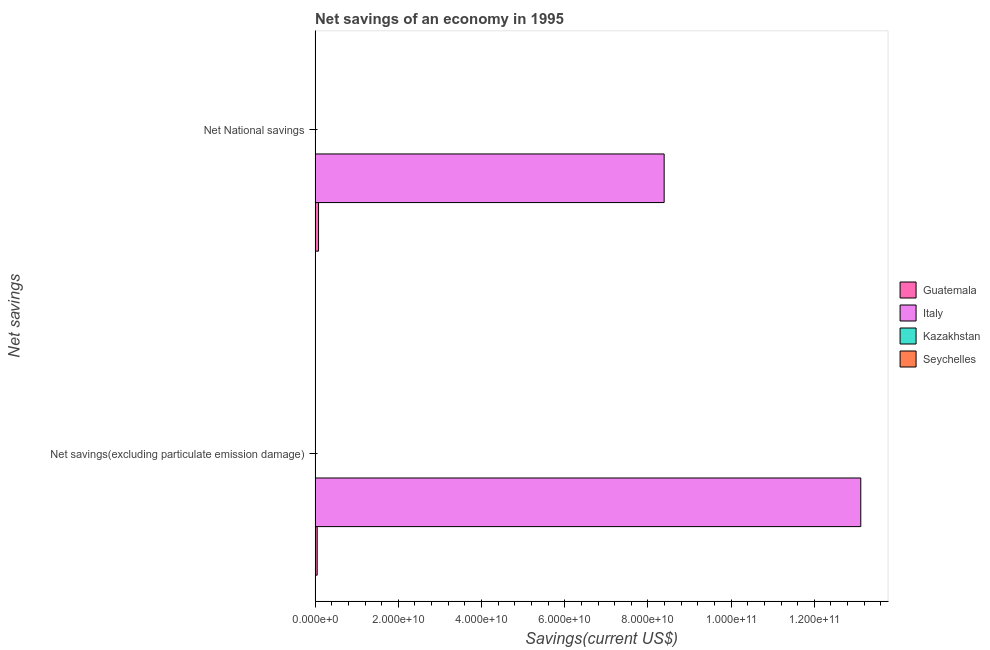How many groups of bars are there?
Your answer should be very brief. 2. How many bars are there on the 1st tick from the top?
Keep it short and to the point. 2. How many bars are there on the 1st tick from the bottom?
Your answer should be very brief. 2. What is the label of the 2nd group of bars from the top?
Keep it short and to the point. Net savings(excluding particulate emission damage). What is the net savings(excluding particulate emission damage) in Seychelles?
Keep it short and to the point. 0. Across all countries, what is the maximum net national savings?
Make the answer very short. 8.39e+1. In which country was the net savings(excluding particulate emission damage) maximum?
Offer a terse response. Italy. What is the total net savings(excluding particulate emission damage) in the graph?
Keep it short and to the point. 1.32e+11. What is the difference between the net savings(excluding particulate emission damage) in Italy and that in Guatemala?
Ensure brevity in your answer.  1.31e+11. What is the difference between the net national savings in Italy and the net savings(excluding particulate emission damage) in Guatemala?
Offer a very short reply. 8.34e+1. What is the average net savings(excluding particulate emission damage) per country?
Your response must be concise. 3.29e+1. What is the difference between the net national savings and net savings(excluding particulate emission damage) in Guatemala?
Ensure brevity in your answer.  3.26e+08. What is the ratio of the net national savings in Guatemala to that in Italy?
Offer a very short reply. 0.01. Is the net national savings in Guatemala less than that in Italy?
Offer a terse response. Yes. Are all the bars in the graph horizontal?
Give a very brief answer. Yes. Are the values on the major ticks of X-axis written in scientific E-notation?
Provide a succinct answer. Yes. How many legend labels are there?
Give a very brief answer. 4. How are the legend labels stacked?
Your answer should be very brief. Vertical. What is the title of the graph?
Your response must be concise. Net savings of an economy in 1995. What is the label or title of the X-axis?
Your answer should be compact. Savings(current US$). What is the label or title of the Y-axis?
Give a very brief answer. Net savings. What is the Savings(current US$) in Guatemala in Net savings(excluding particulate emission damage)?
Ensure brevity in your answer.  5.01e+08. What is the Savings(current US$) in Italy in Net savings(excluding particulate emission damage)?
Your response must be concise. 1.31e+11. What is the Savings(current US$) in Seychelles in Net savings(excluding particulate emission damage)?
Your response must be concise. 0. What is the Savings(current US$) in Guatemala in Net National savings?
Keep it short and to the point. 8.27e+08. What is the Savings(current US$) in Italy in Net National savings?
Give a very brief answer. 8.39e+1. What is the Savings(current US$) of Seychelles in Net National savings?
Keep it short and to the point. 0. Across all Net savings, what is the maximum Savings(current US$) in Guatemala?
Your response must be concise. 8.27e+08. Across all Net savings, what is the maximum Savings(current US$) of Italy?
Your response must be concise. 1.31e+11. Across all Net savings, what is the minimum Savings(current US$) of Guatemala?
Ensure brevity in your answer.  5.01e+08. Across all Net savings, what is the minimum Savings(current US$) in Italy?
Keep it short and to the point. 8.39e+1. What is the total Savings(current US$) in Guatemala in the graph?
Give a very brief answer. 1.33e+09. What is the total Savings(current US$) of Italy in the graph?
Give a very brief answer. 2.15e+11. What is the total Savings(current US$) in Kazakhstan in the graph?
Give a very brief answer. 0. What is the difference between the Savings(current US$) of Guatemala in Net savings(excluding particulate emission damage) and that in Net National savings?
Your answer should be very brief. -3.26e+08. What is the difference between the Savings(current US$) of Italy in Net savings(excluding particulate emission damage) and that in Net National savings?
Your response must be concise. 4.73e+1. What is the difference between the Savings(current US$) in Guatemala in Net savings(excluding particulate emission damage) and the Savings(current US$) in Italy in Net National savings?
Keep it short and to the point. -8.34e+1. What is the average Savings(current US$) in Guatemala per Net savings?
Offer a very short reply. 6.64e+08. What is the average Savings(current US$) in Italy per Net savings?
Offer a terse response. 1.08e+11. What is the average Savings(current US$) of Kazakhstan per Net savings?
Ensure brevity in your answer.  0. What is the difference between the Savings(current US$) of Guatemala and Savings(current US$) of Italy in Net savings(excluding particulate emission damage)?
Provide a succinct answer. -1.31e+11. What is the difference between the Savings(current US$) in Guatemala and Savings(current US$) in Italy in Net National savings?
Make the answer very short. -8.31e+1. What is the ratio of the Savings(current US$) of Guatemala in Net savings(excluding particulate emission damage) to that in Net National savings?
Your response must be concise. 0.61. What is the ratio of the Savings(current US$) of Italy in Net savings(excluding particulate emission damage) to that in Net National savings?
Your answer should be compact. 1.56. What is the difference between the highest and the second highest Savings(current US$) in Guatemala?
Give a very brief answer. 3.26e+08. What is the difference between the highest and the second highest Savings(current US$) in Italy?
Offer a terse response. 4.73e+1. What is the difference between the highest and the lowest Savings(current US$) in Guatemala?
Provide a succinct answer. 3.26e+08. What is the difference between the highest and the lowest Savings(current US$) in Italy?
Provide a succinct answer. 4.73e+1. 